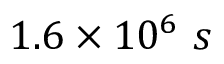Convert formula to latex. <formula><loc_0><loc_0><loc_500><loc_500>1 . 6 \times 1 0 ^ { 6 } \ s</formula> 